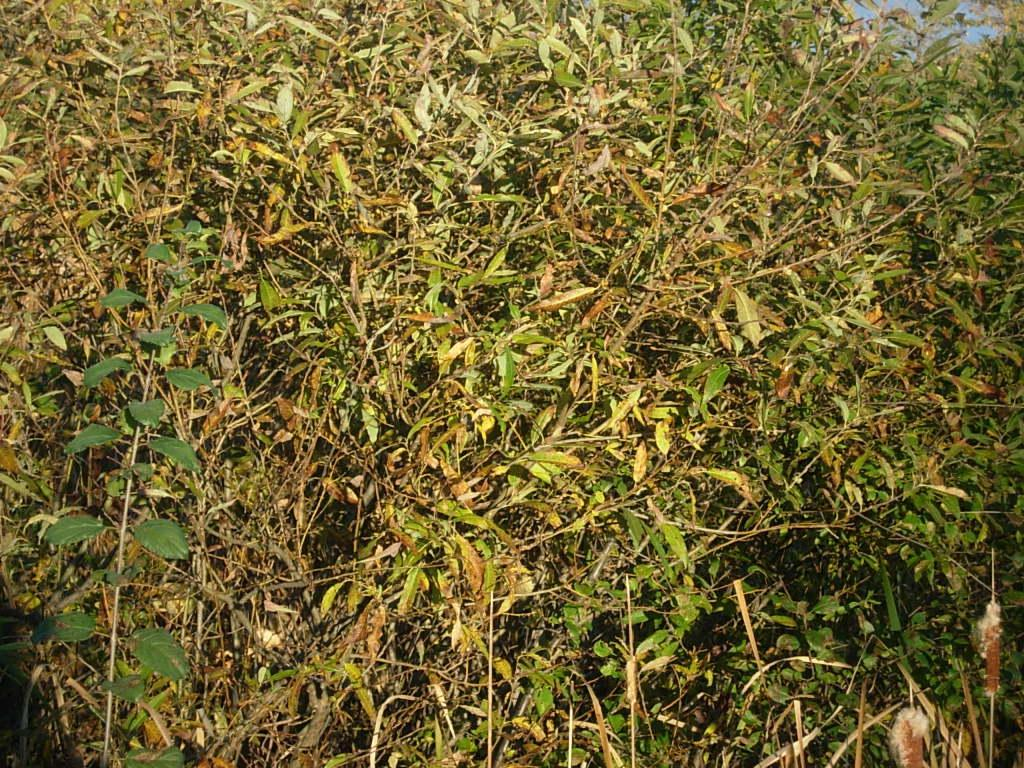What types of living organisms can be seen in the image? The image contains plants. How significant are the plants in the image? The plants are a prominent feature in the image. What thoughts are the plants having about their journey to the church in the image? There is no indication in the image that the plants are thinking or going on a journey, nor is there a church present in the image. 